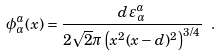Convert formula to latex. <formula><loc_0><loc_0><loc_500><loc_500>\phi _ { \alpha } ^ { a } ( x ) = \frac { d \, \varepsilon _ { \alpha } ^ { a } } { 2 \sqrt { 2 } \pi \left ( x ^ { 2 } ( x - d ) ^ { 2 } \right ) ^ { 3 / 4 } } \ .</formula> 